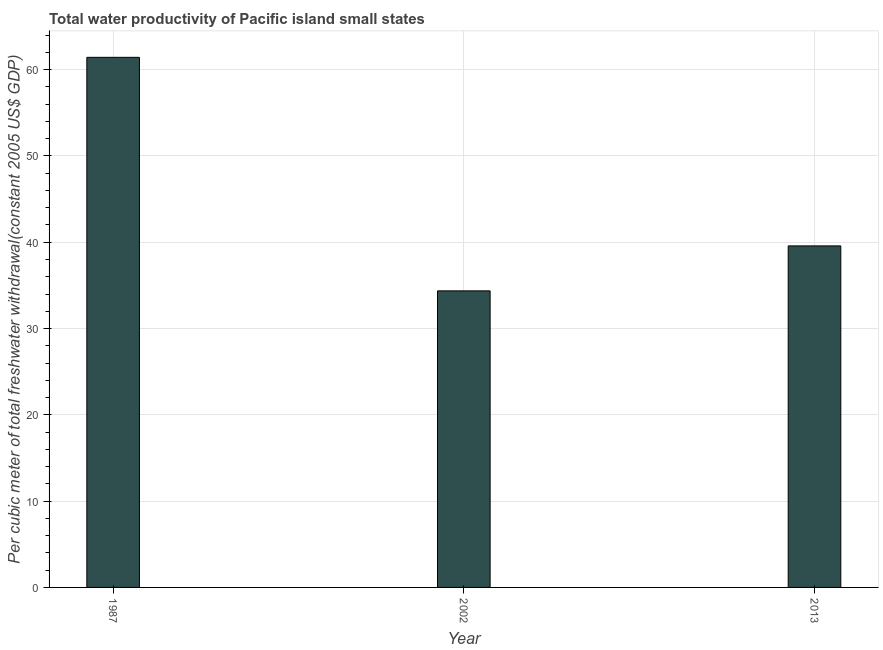Does the graph contain any zero values?
Offer a terse response. No. Does the graph contain grids?
Make the answer very short. Yes. What is the title of the graph?
Make the answer very short. Total water productivity of Pacific island small states. What is the label or title of the X-axis?
Offer a very short reply. Year. What is the label or title of the Y-axis?
Your response must be concise. Per cubic meter of total freshwater withdrawal(constant 2005 US$ GDP). What is the total water productivity in 1987?
Offer a very short reply. 61.42. Across all years, what is the maximum total water productivity?
Provide a short and direct response. 61.42. Across all years, what is the minimum total water productivity?
Ensure brevity in your answer.  34.36. In which year was the total water productivity minimum?
Provide a short and direct response. 2002. What is the sum of the total water productivity?
Give a very brief answer. 135.36. What is the difference between the total water productivity in 1987 and 2013?
Offer a very short reply. 21.85. What is the average total water productivity per year?
Ensure brevity in your answer.  45.12. What is the median total water productivity?
Make the answer very short. 39.57. In how many years, is the total water productivity greater than 58 US$?
Make the answer very short. 1. Do a majority of the years between 2002 and 2013 (inclusive) have total water productivity greater than 56 US$?
Your answer should be very brief. No. What is the ratio of the total water productivity in 1987 to that in 2002?
Your response must be concise. 1.79. What is the difference between the highest and the second highest total water productivity?
Offer a terse response. 21.85. What is the difference between the highest and the lowest total water productivity?
Provide a short and direct response. 27.06. How many bars are there?
Your answer should be very brief. 3. Are all the bars in the graph horizontal?
Your answer should be compact. No. How many years are there in the graph?
Provide a short and direct response. 3. What is the difference between two consecutive major ticks on the Y-axis?
Your response must be concise. 10. What is the Per cubic meter of total freshwater withdrawal(constant 2005 US$ GDP) in 1987?
Your answer should be compact. 61.42. What is the Per cubic meter of total freshwater withdrawal(constant 2005 US$ GDP) in 2002?
Offer a terse response. 34.36. What is the Per cubic meter of total freshwater withdrawal(constant 2005 US$ GDP) in 2013?
Give a very brief answer. 39.57. What is the difference between the Per cubic meter of total freshwater withdrawal(constant 2005 US$ GDP) in 1987 and 2002?
Offer a terse response. 27.06. What is the difference between the Per cubic meter of total freshwater withdrawal(constant 2005 US$ GDP) in 1987 and 2013?
Your response must be concise. 21.85. What is the difference between the Per cubic meter of total freshwater withdrawal(constant 2005 US$ GDP) in 2002 and 2013?
Offer a terse response. -5.21. What is the ratio of the Per cubic meter of total freshwater withdrawal(constant 2005 US$ GDP) in 1987 to that in 2002?
Your answer should be very brief. 1.79. What is the ratio of the Per cubic meter of total freshwater withdrawal(constant 2005 US$ GDP) in 1987 to that in 2013?
Keep it short and to the point. 1.55. What is the ratio of the Per cubic meter of total freshwater withdrawal(constant 2005 US$ GDP) in 2002 to that in 2013?
Ensure brevity in your answer.  0.87. 